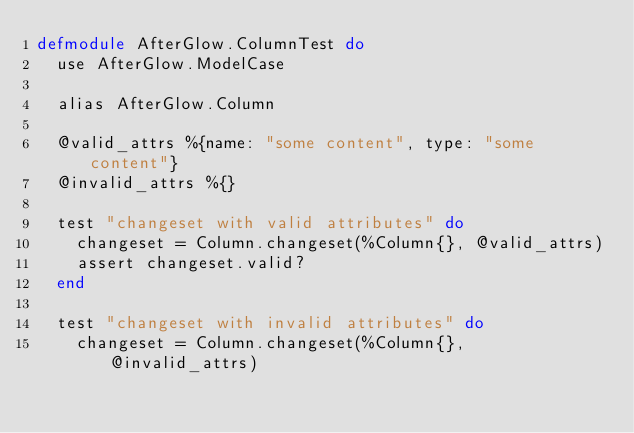<code> <loc_0><loc_0><loc_500><loc_500><_Elixir_>defmodule AfterGlow.ColumnTest do
  use AfterGlow.ModelCase

  alias AfterGlow.Column

  @valid_attrs %{name: "some content", type: "some content"}
  @invalid_attrs %{}

  test "changeset with valid attributes" do
    changeset = Column.changeset(%Column{}, @valid_attrs)
    assert changeset.valid?
  end

  test "changeset with invalid attributes" do
    changeset = Column.changeset(%Column{}, @invalid_attrs)</code> 